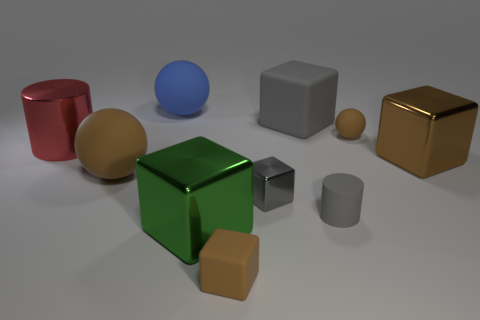What number of other big rubber things have the same shape as the large green thing?
Offer a very short reply. 1. How many objects are either big cubes in front of the big metal cylinder or big balls to the left of the green thing?
Your response must be concise. 4. What material is the cylinder behind the metal block that is to the right of the gray cube that is behind the large red metal cylinder?
Your answer should be compact. Metal. Do the cylinder that is to the left of the gray rubber block and the tiny rubber sphere have the same color?
Offer a terse response. No. What is the sphere that is behind the red metallic thing and to the left of the tiny gray rubber object made of?
Keep it short and to the point. Rubber. Is there a brown matte object that has the same size as the gray metallic block?
Your response must be concise. Yes. What number of metal balls are there?
Ensure brevity in your answer.  0. There is a brown shiny thing; how many spheres are behind it?
Provide a short and direct response. 2. Does the tiny brown block have the same material as the tiny gray cylinder?
Give a very brief answer. Yes. What number of big things are to the right of the tiny brown block and behind the brown metal object?
Your response must be concise. 1. 